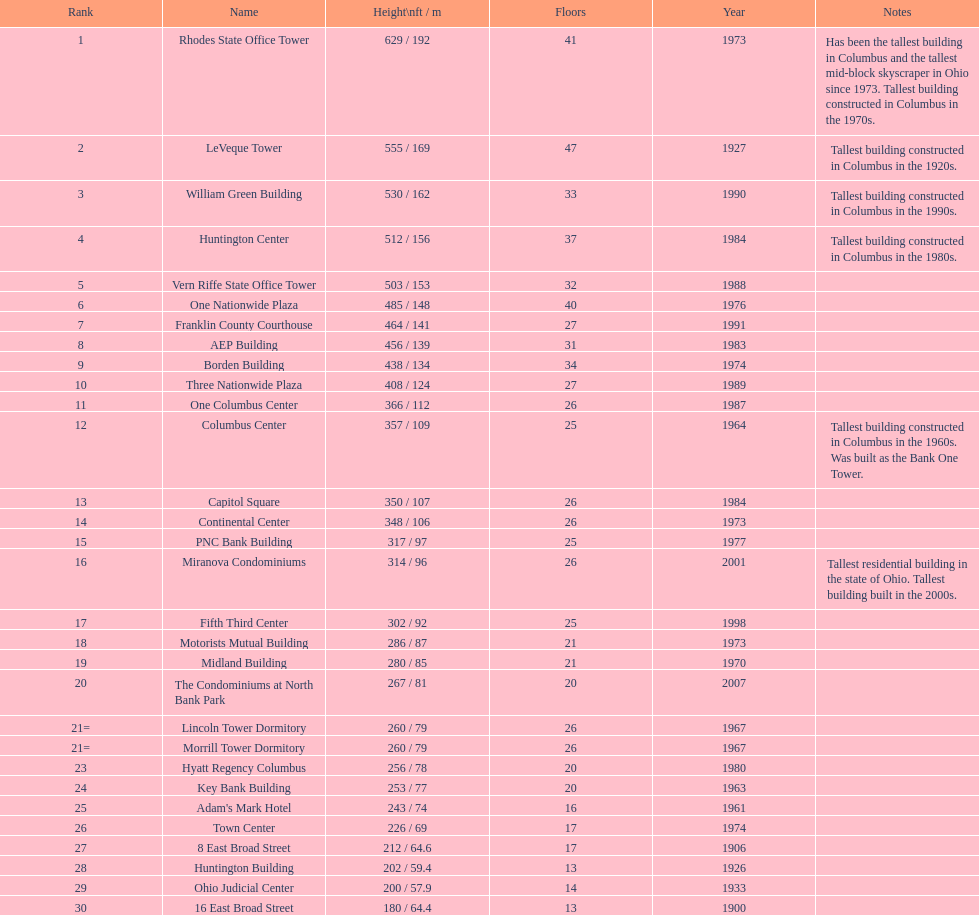Which structures have a height exceeding 500 feet? Rhodes State Office Tower, LeVeque Tower, William Green Building, Huntington Center, Vern Riffe State Office Tower. 